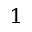Convert formula to latex. <formula><loc_0><loc_0><loc_500><loc_500>_ { 1 }</formula> 